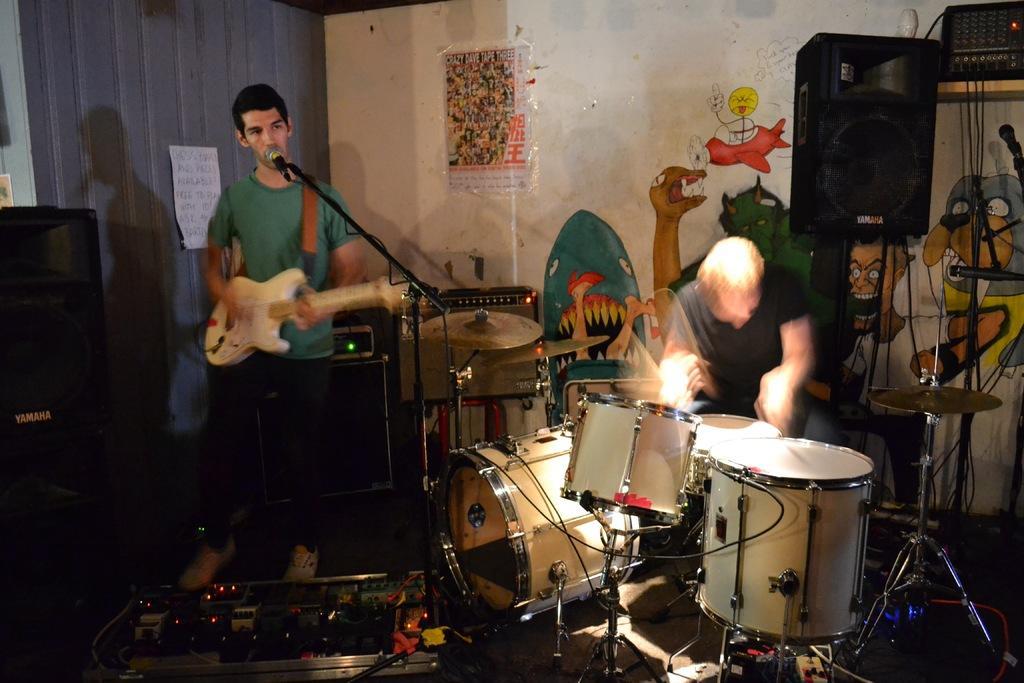Can you describe this image briefly? In this picture I can see 2 men, where I see the man on the left is holding a guitar and standing in front of a mic and the man on the right is holding sticks and is sitting near to the drums and I see few other equipment. On the right top of this picture, I can see a speaker and few wires. In the background I can see the wall on which I can see the art of cartoon characters. 